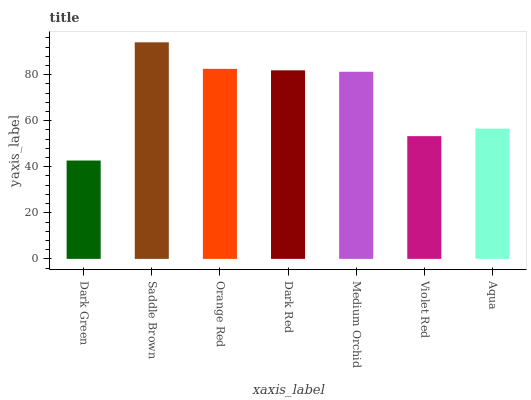Is Dark Green the minimum?
Answer yes or no. Yes. Is Saddle Brown the maximum?
Answer yes or no. Yes. Is Orange Red the minimum?
Answer yes or no. No. Is Orange Red the maximum?
Answer yes or no. No. Is Saddle Brown greater than Orange Red?
Answer yes or no. Yes. Is Orange Red less than Saddle Brown?
Answer yes or no. Yes. Is Orange Red greater than Saddle Brown?
Answer yes or no. No. Is Saddle Brown less than Orange Red?
Answer yes or no. No. Is Medium Orchid the high median?
Answer yes or no. Yes. Is Medium Orchid the low median?
Answer yes or no. Yes. Is Dark Green the high median?
Answer yes or no. No. Is Aqua the low median?
Answer yes or no. No. 